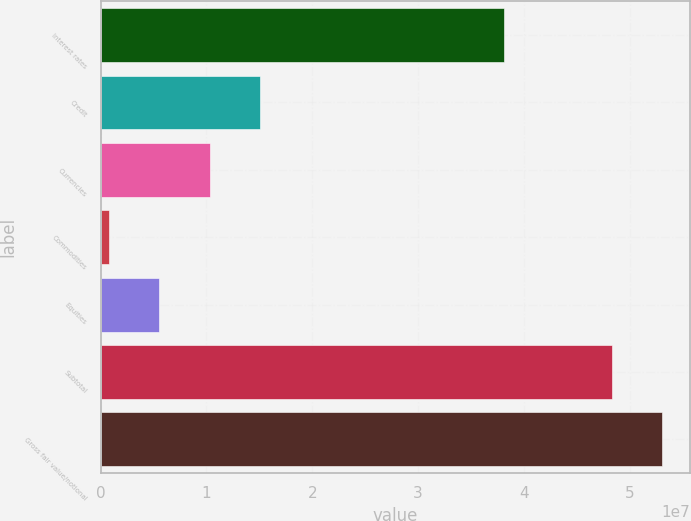<chart> <loc_0><loc_0><loc_500><loc_500><bar_chart><fcel>Interest rates<fcel>Credit<fcel>Currencies<fcel>Commodities<fcel>Equities<fcel>Subtotal<fcel>Gross fair value/notional<nl><fcel>3.81111e+07<fcel>1.50842e+07<fcel>1.03228e+07<fcel>799925<fcel>5.56135e+06<fcel>4.8296e+07<fcel>5.30574e+07<nl></chart> 